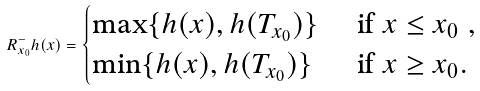Convert formula to latex. <formula><loc_0><loc_0><loc_500><loc_500>R ^ { - } _ { x _ { 0 } } h ( x ) = \begin{cases} \max \{ h ( x ) , h ( T _ { x _ { 0 } } ) \} & \text { if $x\leq x_{0}$ } , \\ \min \{ h ( x ) , h ( T _ { x _ { 0 } } ) \} & \text { if $x\geq x_{0}$} . \end{cases}</formula> 